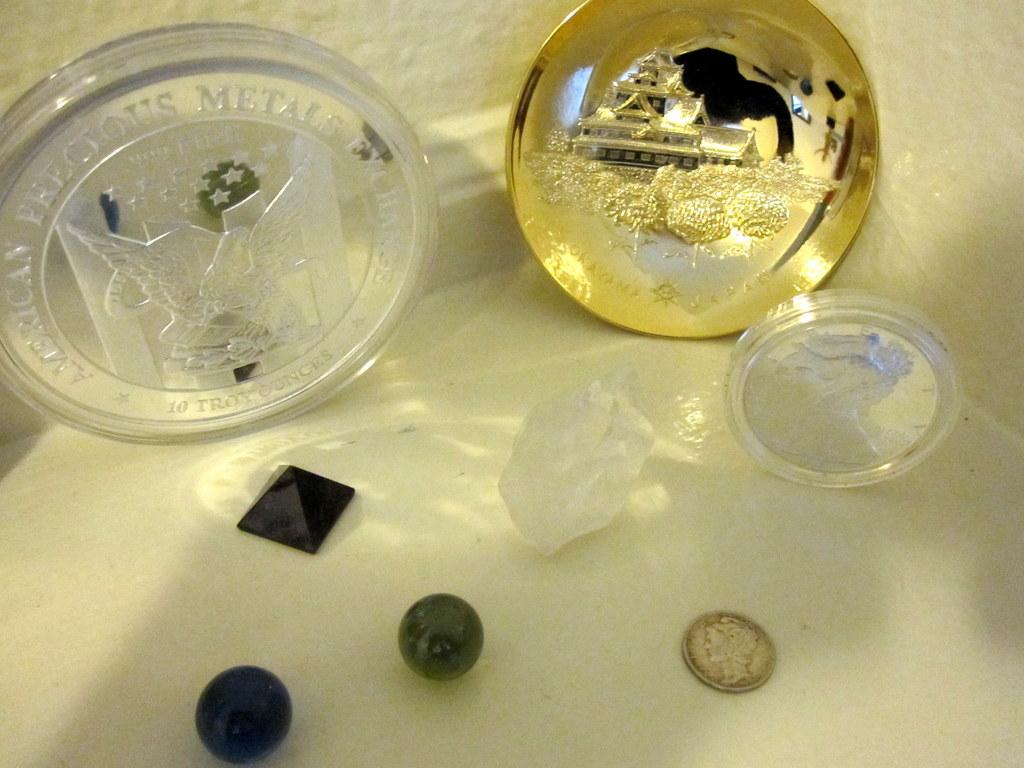What does the large silver coin on the left say?
Provide a short and direct response. Unanswerable. Where was this made?
Offer a very short reply. America. 